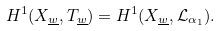Convert formula to latex. <formula><loc_0><loc_0><loc_500><loc_500>H ^ { 1 } ( X _ { \underline { w } } , T _ { \underline { w } } ) = H ^ { 1 } ( X _ { \underline { w } } , \mathcal { L } _ { \alpha _ { 1 } } ) .</formula> 